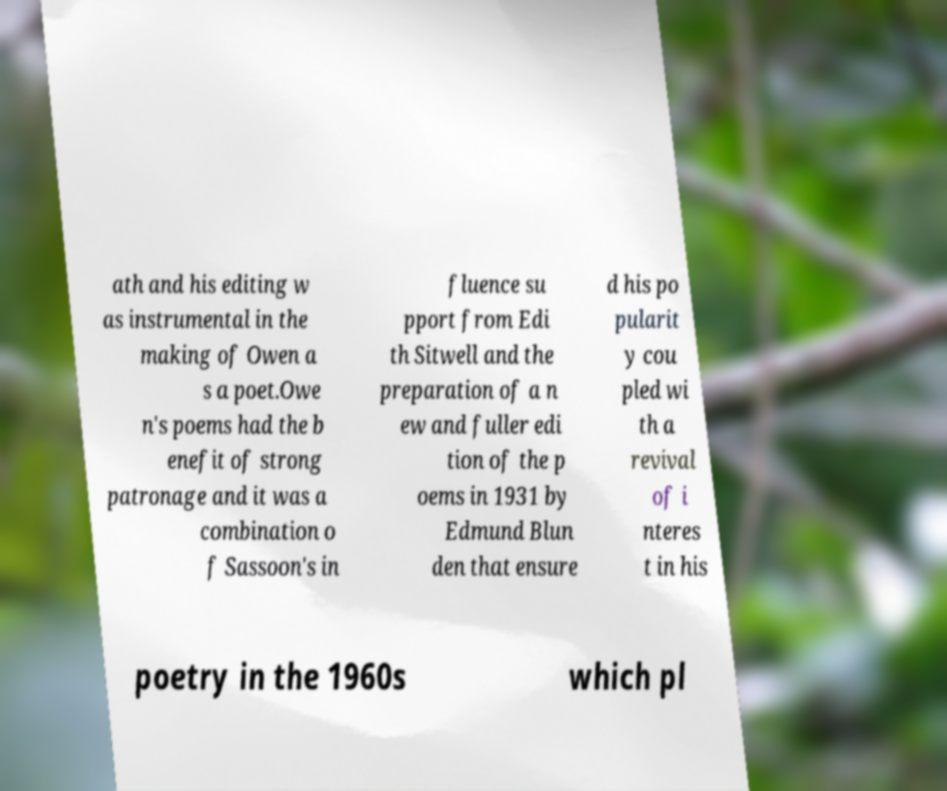Please identify and transcribe the text found in this image. ath and his editing w as instrumental in the making of Owen a s a poet.Owe n's poems had the b enefit of strong patronage and it was a combination o f Sassoon's in fluence su pport from Edi th Sitwell and the preparation of a n ew and fuller edi tion of the p oems in 1931 by Edmund Blun den that ensure d his po pularit y cou pled wi th a revival of i nteres t in his poetry in the 1960s which pl 